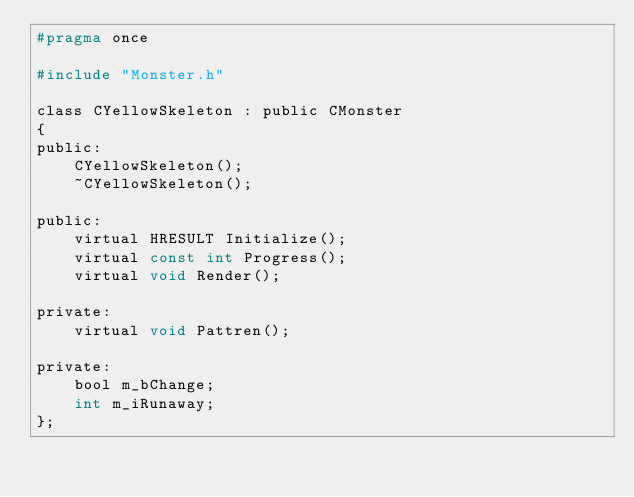Convert code to text. <code><loc_0><loc_0><loc_500><loc_500><_C_>#pragma once

#include "Monster.h"

class CYellowSkeleton : public CMonster
{
public:
	CYellowSkeleton();
	~CYellowSkeleton();

public:
	virtual HRESULT Initialize();
	virtual const int Progress();
	virtual void Render();

private:
	virtual void Pattren();

private:
	bool m_bChange;
	int m_iRunaway;
};</code> 